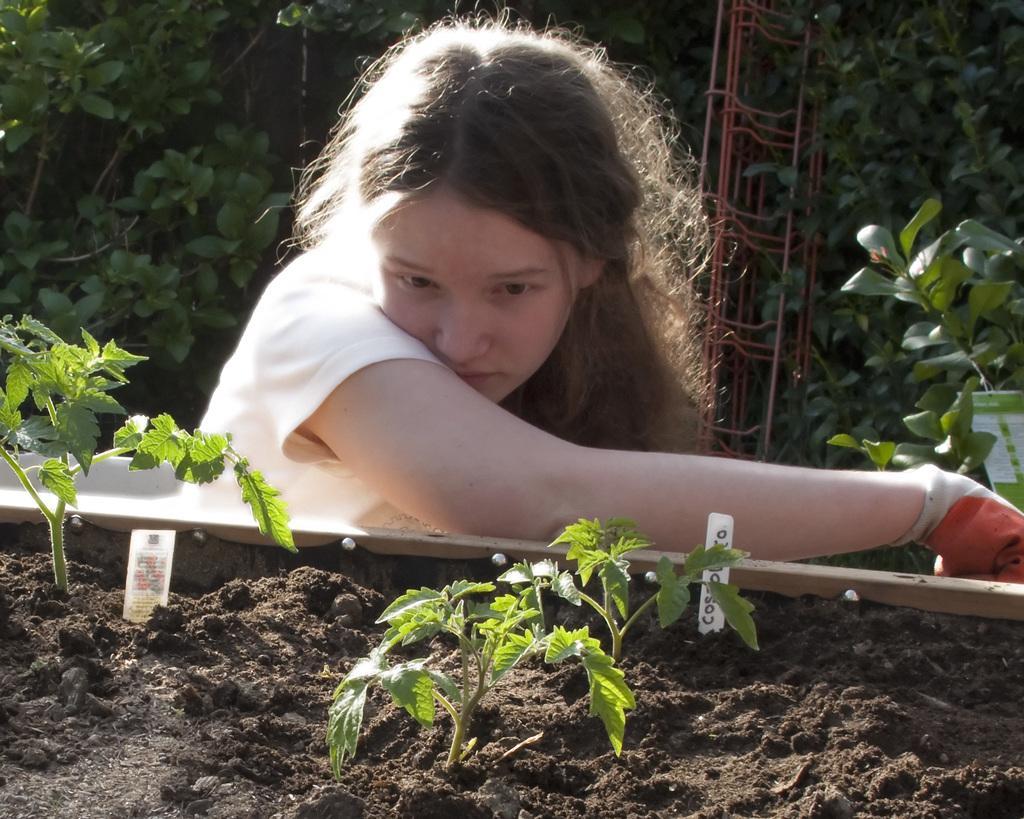Could you give a brief overview of what you see in this image? In this picture we can see a woman, she wore a glove, in front of her we can find few plants, in the background we can see few metal rods. 